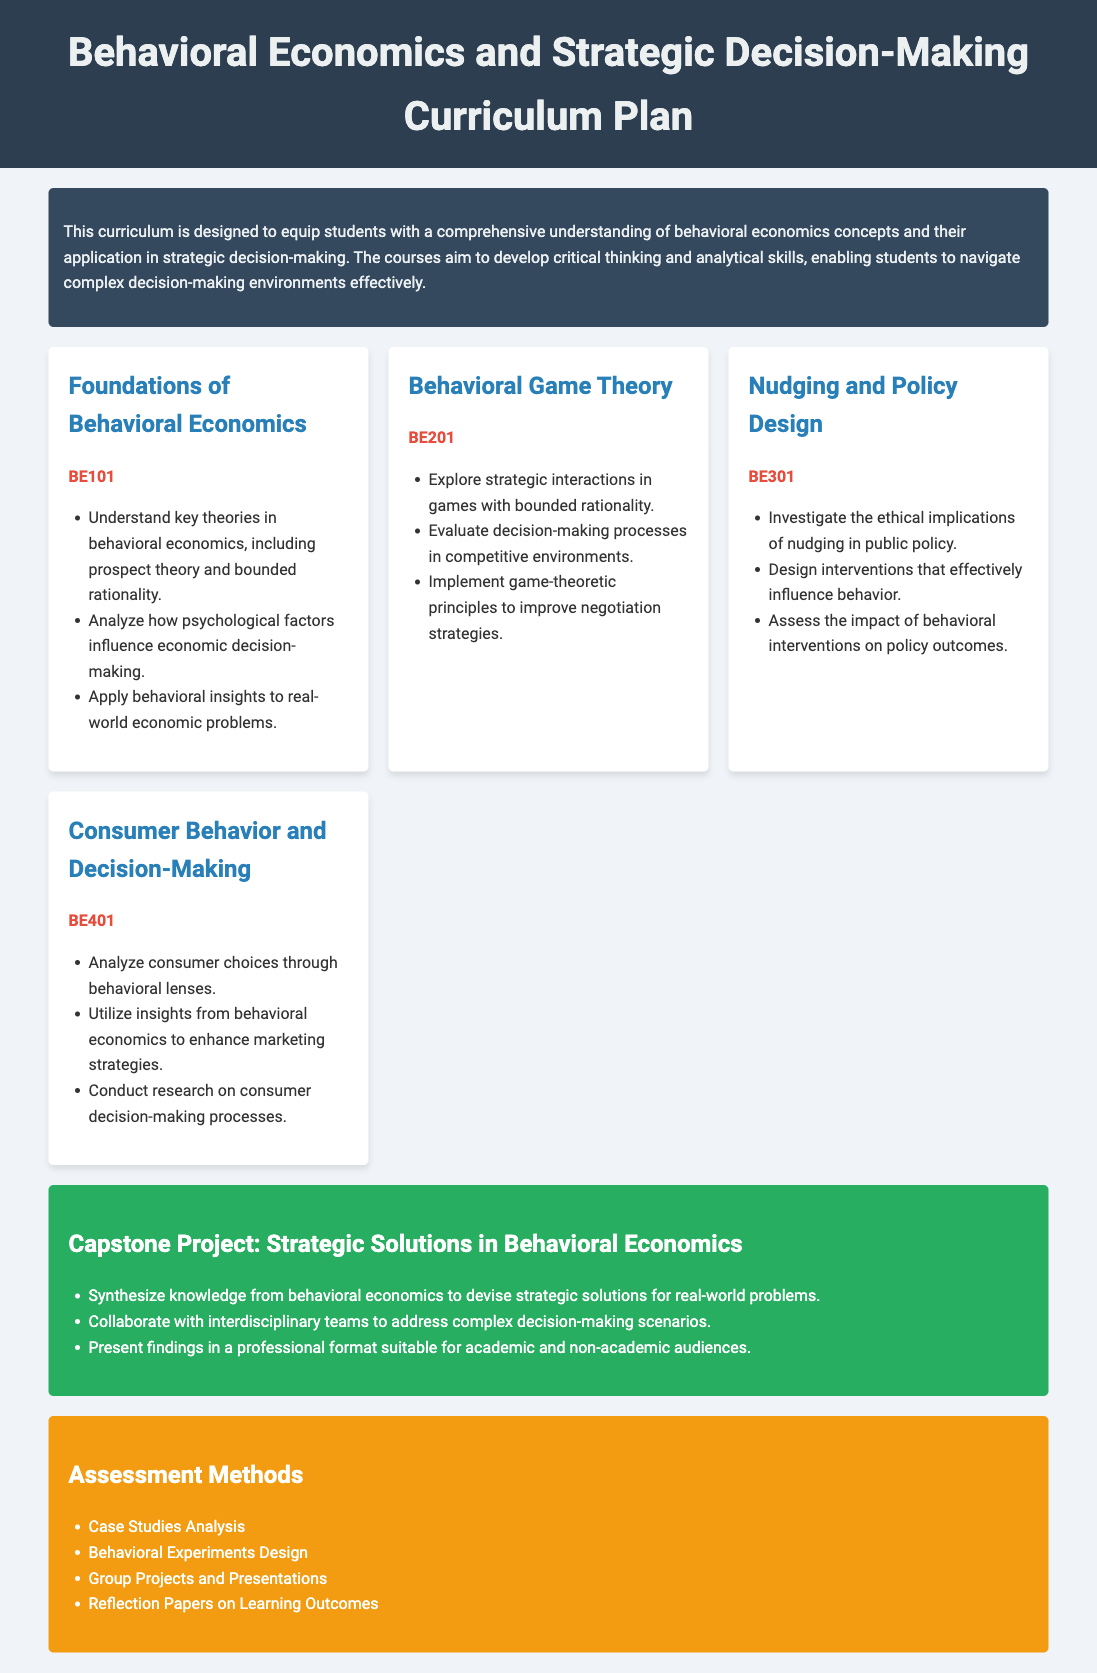What is the title of the curriculum? The title clearly stated at the top of the document is indicative of the curriculum’s focus on behavioral economics and decision-making processes.
Answer: Behavioral Economics and Strategic Decision-Making Curriculum Plan How many courses are included in the curriculum? The document presents a list of four distinct courses within the curriculum.
Answer: Four What is the course code for Behavioral Game Theory? Each course is accompanied by a specific code for identification, with Behavioral Game Theory clearly labeled.
Answer: BE201 What is the objective of the capstone project? The capstone project is designed to utilize knowledge from previous coursework to address real-world issues, highlighting a practical application of behavioral economics.
Answer: Strategic Solutions in Behavioral Economics Which course focuses on consumer choices? The document explicitly includes a course that centers on the analysis of consumer choices through behavioral lenses.
Answer: Consumer Behavior and Decision-Making What type of assessment method involves designing experiments? The assessment methods section describes various ways of evaluating students' work, including one specific method that involves experimental setup.
Answer: Behavioral Experiments Design What is one ethical aspect explored in the Nudging and Policy Design course? The course clearly mentions the investigation of ethical implications associated with a specific strategy in public policy.
Answer: Ethical implications of nudging Which color is used for the assessment section? The document uses a specific color to visually differentiate the assessment methods section from other parts of the curriculum.
Answer: Orange 